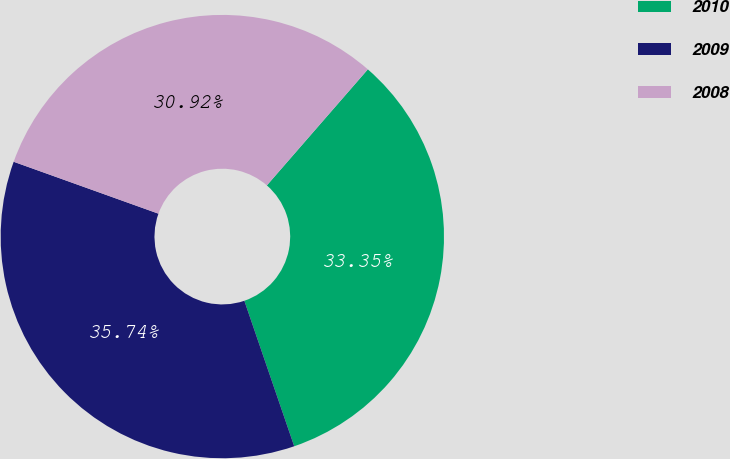Convert chart. <chart><loc_0><loc_0><loc_500><loc_500><pie_chart><fcel>2010<fcel>2009<fcel>2008<nl><fcel>33.35%<fcel>35.74%<fcel>30.92%<nl></chart> 